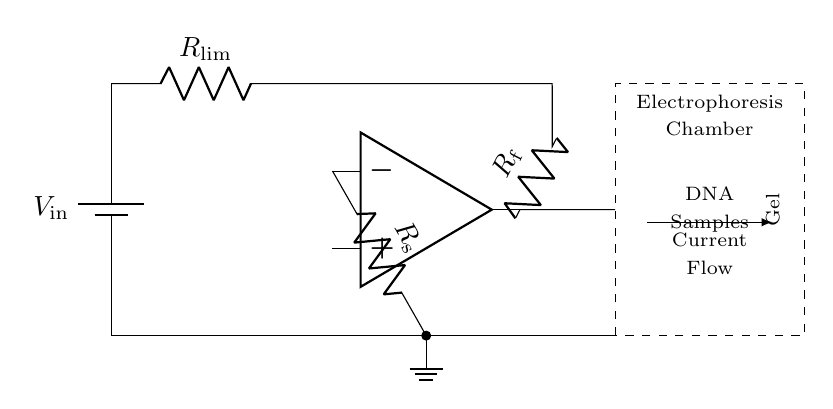What is the current-limiting resistor used for? The current-limiting resistor is used to prevent excessive current flow through the circuit, protecting sensitive components, particularly the electrophoresis equipment.
Answer: Current protection What type of amplifier is represented in the circuit? The operational amplifier, indicated in the circuit, is used for amplifying voltage signals and controlling the current to the electrophoresis chamber based on the feedback and shunt resistors.
Answer: Operational What does the feedback resistor do in this circuit? The feedback resistor connects the output of the operational amplifier to its inverting input, allowing for control of the gain and stability of the circuit while helping regulate the current supplied to the circuit.
Answer: Regulates gain What is the role of the shunt resistor in the circuit? The shunt resistor measures the current flowing through it by creating a proportional voltage drop, feeding this information back to the operational amplifier to adjust the output current accordingly.
Answer: Current measurement What is the voltage source in this circuit labeled as? The voltage source that powers the circuit is labeled as V in, indicating the input voltage for operating the entire current-limiting setup.
Answer: V in How is current flow directed in this circuit? Current flow is directed through the various components, starting from the battery, passing through the current-limiting resistor, operational amplifier, and finally to the electrophoresis chamber, indicating the path of electricity in the diagram.
Answer: From battery to chamber 